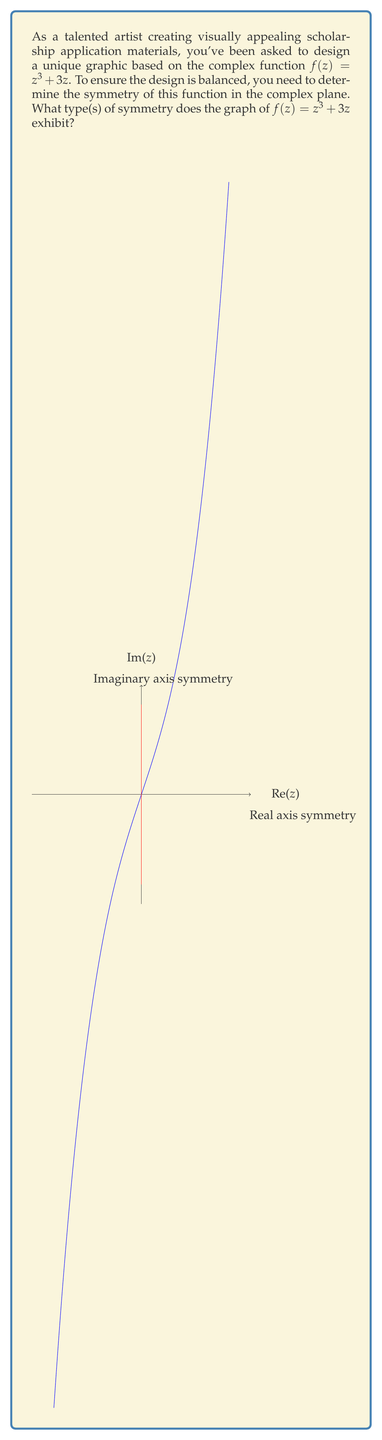Can you solve this math problem? To determine the symmetry of the complex function $f(z) = z^3 + 3z$, we need to examine how the function behaves under different transformations:

1. Real axis symmetry:
   Let $z = x + yi$. We need to check if $f(\overline{z}) = \overline{f(z)}$.
   
   $f(\overline{z}) = (x - yi)^3 + 3(x - yi)$
                    $= (x^3 - 3x^2yi - 3xy^2 + y^3i) + (3x - 3yi)$
                    $= (x^3 - 3xy^2 + 3x) + (-3x^2y + y^3 - 3y)i$
   
   $\overline{f(z)} = \overline{(x + yi)^3 + 3(x + yi)}$
                    $= \overline{(x^3 - 3xy^2 + 3x) + (3x^2y - y^3 + 3y)i}$
                    $= (x^3 - 3xy^2 + 3x) + (-3x^2y + y^3 - 3y)i$
   
   Since $f(\overline{z}) = \overline{f(z)}$, the function has symmetry about the real axis.

2. Imaginary axis symmetry:
   We need to check if $f(-z) = -f(z)$.
   
   $f(-z) = (-z)^3 + 3(-z) = -z^3 - 3z = -(z^3 + 3z) = -f(z)$
   
   This confirms that the function has symmetry about the imaginary axis.

3. Origin symmetry:
   The function has both real and imaginary axis symmetry, which implies it also has symmetry about the origin (rotational symmetry of 180°).

The graph in the question visually demonstrates these symmetries, with the blue curve showing the behavior along the real axis and the red curve showing the behavior along the imaginary axis.
Answer: Real axis symmetry, imaginary axis symmetry, and origin symmetry 